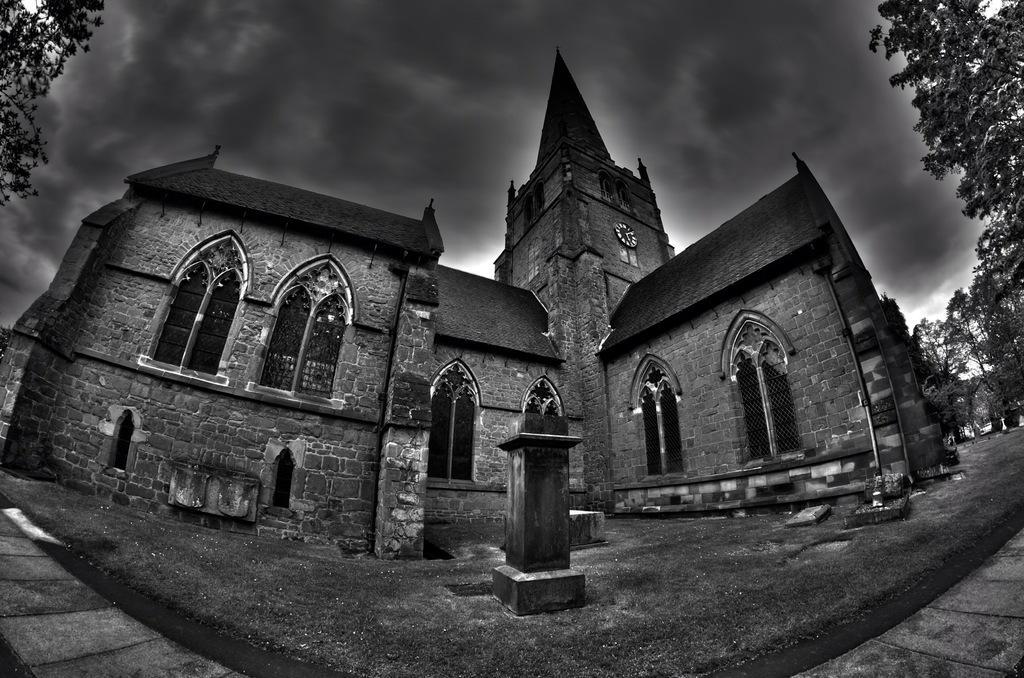Can you describe this image briefly? In this black and white image there is a building. On the left and right side of the image there are trees. In the background there is the sky with clouds. 